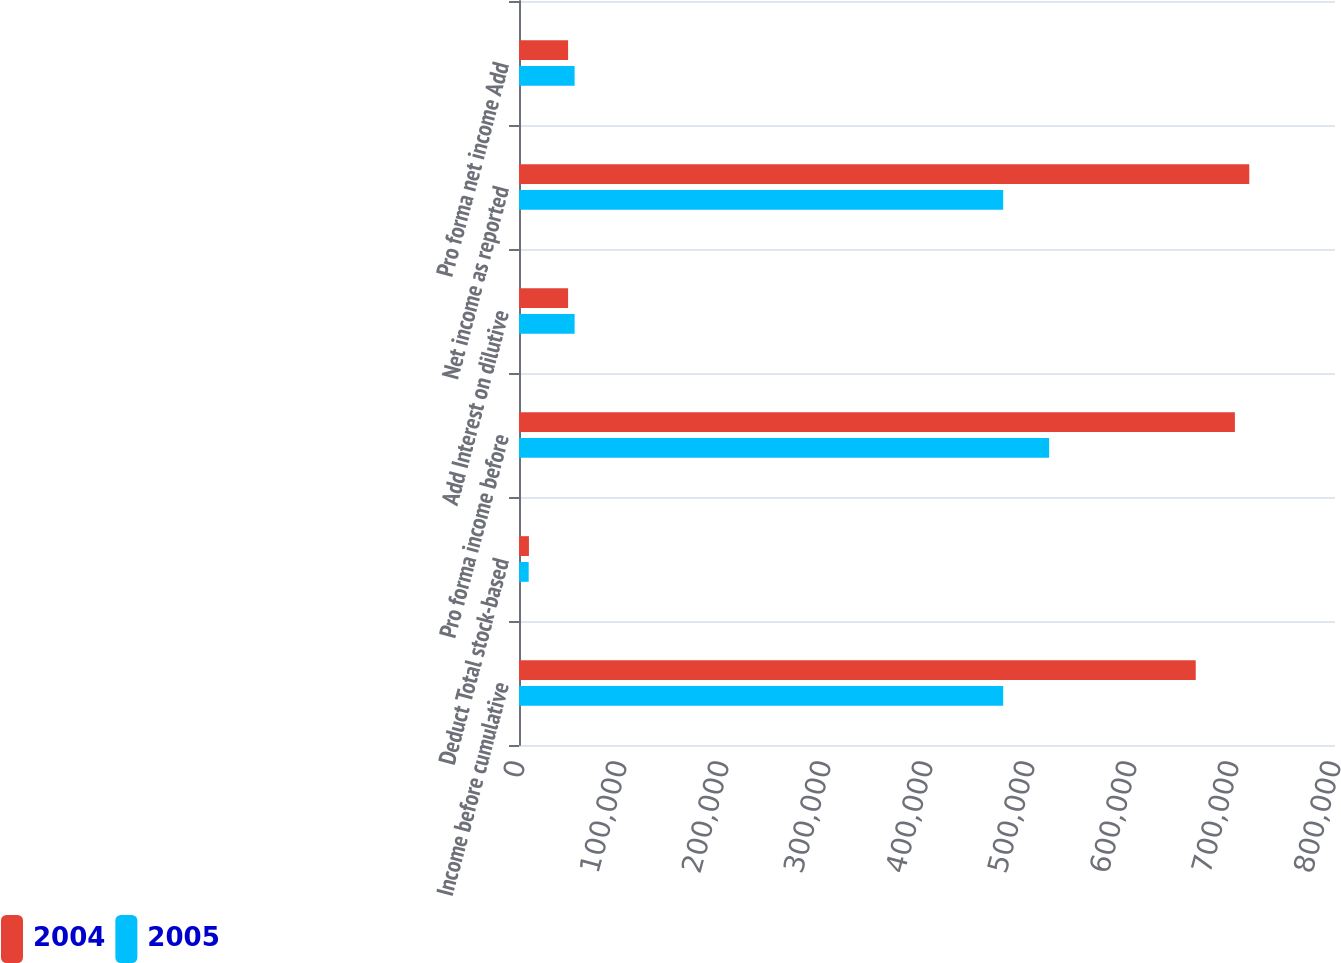<chart> <loc_0><loc_0><loc_500><loc_500><stacked_bar_chart><ecel><fcel>Income before cumulative<fcel>Deduct Total stock-based<fcel>Pro forma income before<fcel>Add Interest on dilutive<fcel>Net income as reported<fcel>Pro forma net income Add<nl><fcel>2004<fcel>663465<fcel>9732<fcel>701861<fcel>48128<fcel>715956<fcel>48128<nl><fcel>2005<fcel>474691<fcel>9502<fcel>519719<fcel>54530<fcel>474691<fcel>54530<nl></chart> 